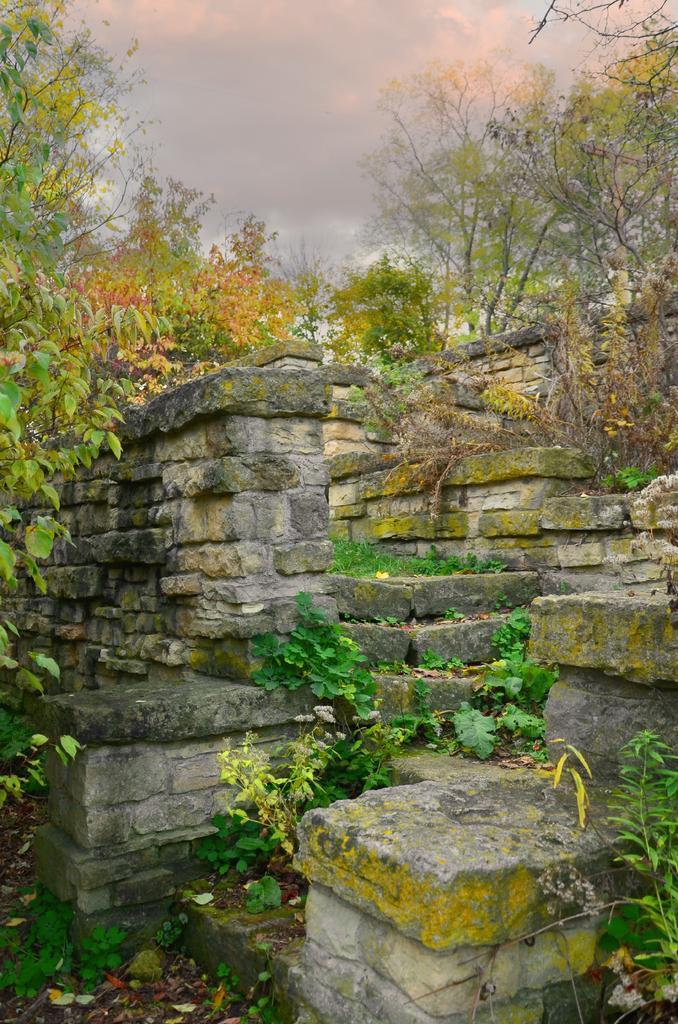Can you describe this image briefly? Here we can see wall,plants and in the background there are trees and clouds in the sky. 